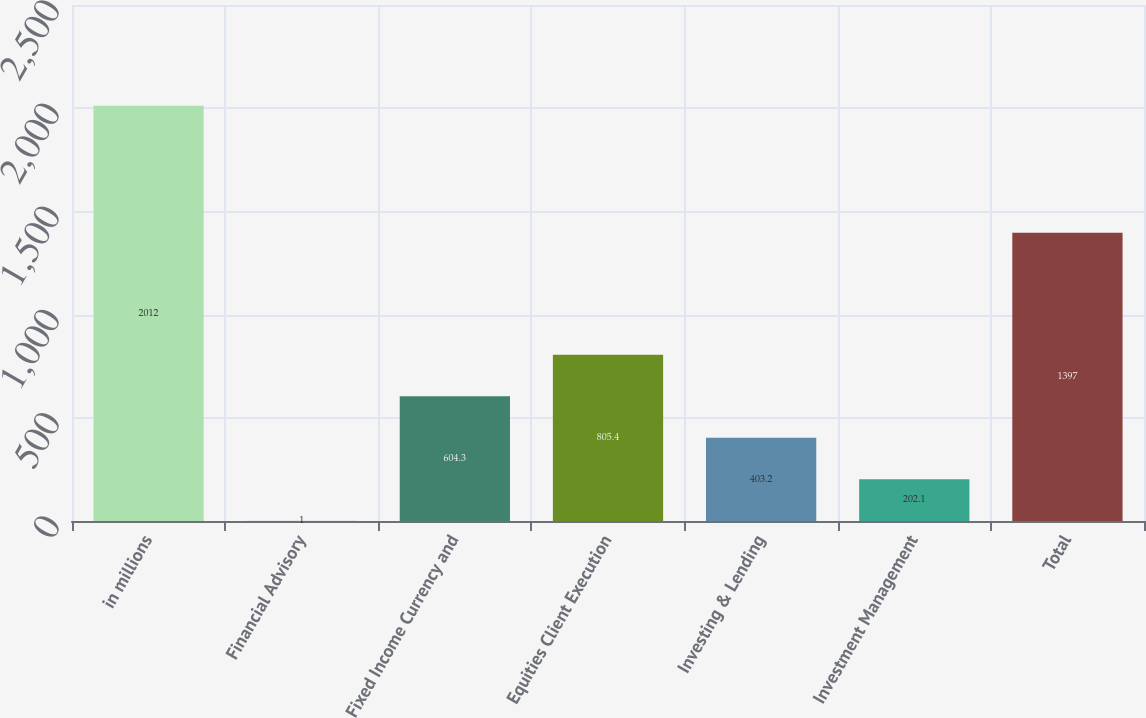<chart> <loc_0><loc_0><loc_500><loc_500><bar_chart><fcel>in millions<fcel>Financial Advisory<fcel>Fixed Income Currency and<fcel>Equities Client Execution<fcel>Investing & Lending<fcel>Investment Management<fcel>Total<nl><fcel>2012<fcel>1<fcel>604.3<fcel>805.4<fcel>403.2<fcel>202.1<fcel>1397<nl></chart> 